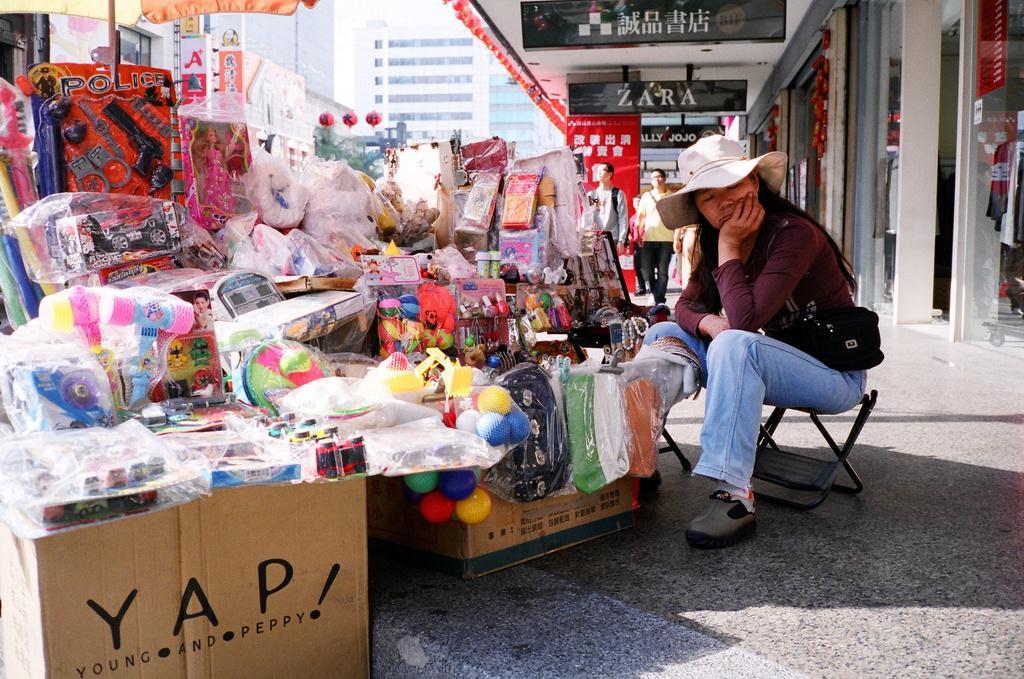Describe this image in one or two sentences. In this picture a lady is sitting on a chair with objects in front of her. We also observed many labels which are named a zara, jojo. 